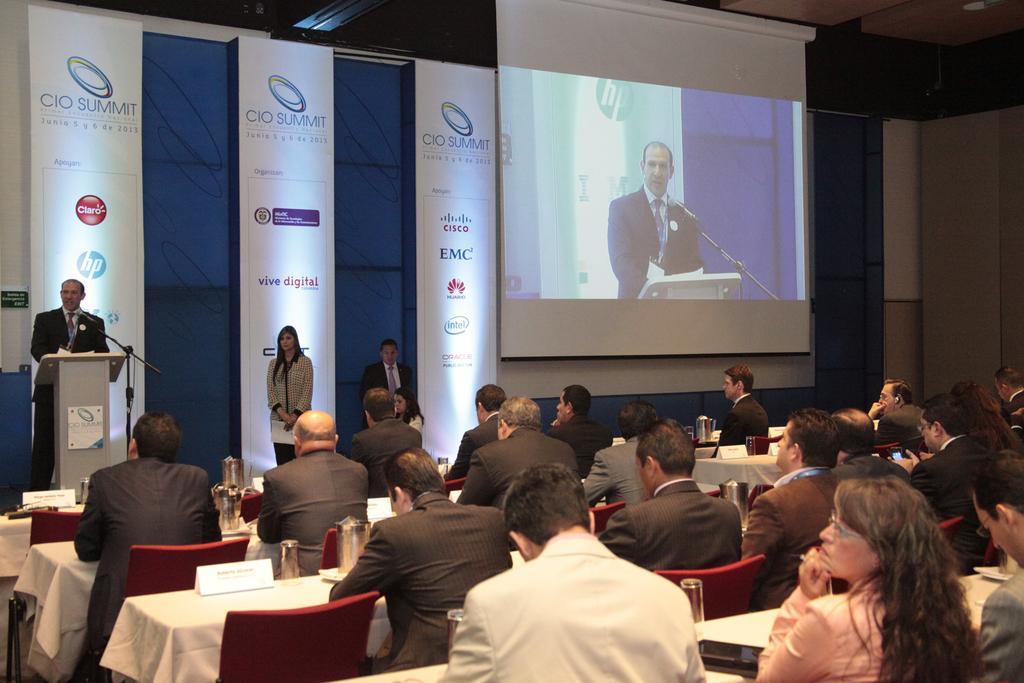Describe this image in one or two sentences. In this image it seems like a summit in which the person standing near the podium is giving a speech to the people who are sitting. There is a table in front of the person who is sitting. On the table there is jug and a name board. On the top there is a projector. There are banners near the wall. 